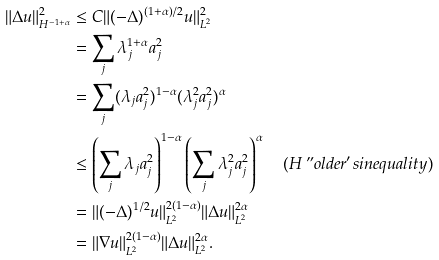Convert formula to latex. <formula><loc_0><loc_0><loc_500><loc_500>\| \Delta u \| _ { H ^ { - 1 + \alpha } } ^ { 2 } & \leq C \| ( - \Delta ) ^ { ( 1 + \alpha ) / 2 } u \| _ { L ^ { 2 } } ^ { 2 } \\ & = \sum _ { j } \lambda _ { j } ^ { 1 + \alpha } a _ { j } ^ { 2 } \\ & = \sum _ { j } ( \lambda _ { j } a _ { j } ^ { 2 } ) ^ { 1 - \alpha } ( \lambda _ { j } ^ { 2 } a _ { j } ^ { 2 } ) ^ { \alpha } \\ & \leq \left ( \sum _ { j } \lambda _ { j } a _ { j } ^ { 2 } \right ) ^ { 1 - \alpha } \left ( \sum _ { j } \lambda _ { j } ^ { 2 } a _ { j } ^ { 2 } \right ) ^ { \alpha } \quad ( H \ " o l d e r ^ { \prime } s i n e q u a l i t y ) \\ & = \| ( - \Delta ) ^ { 1 / 2 } u \| _ { L ^ { 2 } } ^ { 2 ( 1 - \alpha ) } \| \Delta u \| _ { L ^ { 2 } } ^ { 2 \alpha } \\ & = \| \nabla u \| _ { L ^ { 2 } } ^ { 2 ( 1 - \alpha ) } \| \Delta u \| _ { L ^ { 2 } } ^ { 2 \alpha } .</formula> 